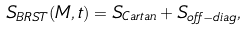<formula> <loc_0><loc_0><loc_500><loc_500>S _ { B R S T } ( M , t ) = S _ { C a r t a n } + S _ { o f f - d i a g } ,</formula> 